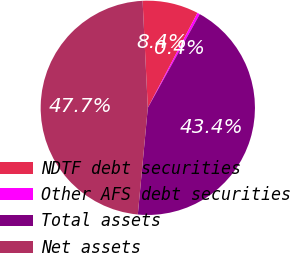Convert chart. <chart><loc_0><loc_0><loc_500><loc_500><pie_chart><fcel>NDTF debt securities<fcel>Other AFS debt securities<fcel>Total assets<fcel>Net assets<nl><fcel>8.44%<fcel>0.39%<fcel>43.43%<fcel>47.74%<nl></chart> 